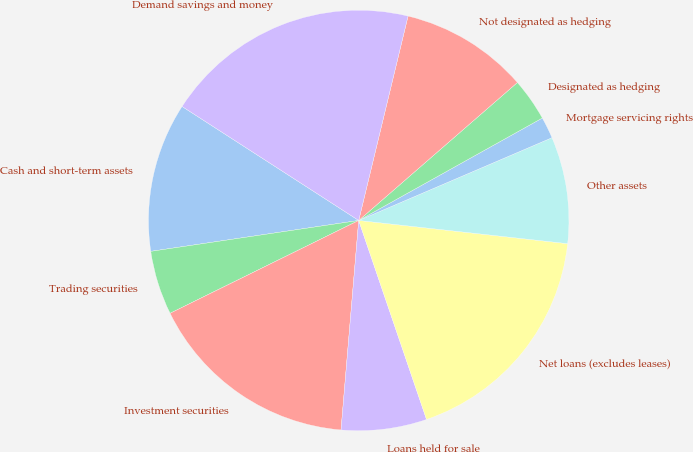Convert chart to OTSL. <chart><loc_0><loc_0><loc_500><loc_500><pie_chart><fcel>Cash and short-term assets<fcel>Trading securities<fcel>Investment securities<fcel>Loans held for sale<fcel>Net loans (excludes leases)<fcel>Other assets<fcel>Mortgage servicing rights<fcel>Designated as hedging<fcel>Not designated as hedging<fcel>Demand savings and money<nl><fcel>11.47%<fcel>4.93%<fcel>16.38%<fcel>6.57%<fcel>18.01%<fcel>8.2%<fcel>1.66%<fcel>3.29%<fcel>9.84%<fcel>19.65%<nl></chart> 